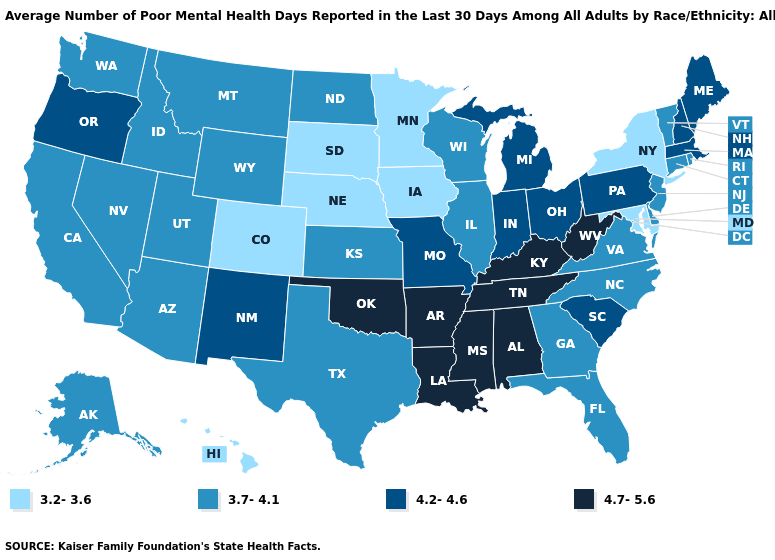Does North Carolina have the same value as South Carolina?
Give a very brief answer. No. What is the value of Florida?
Be succinct. 3.7-4.1. What is the value of Vermont?
Be succinct. 3.7-4.1. What is the value of Indiana?
Give a very brief answer. 4.2-4.6. Does Illinois have the highest value in the MidWest?
Be succinct. No. Does Utah have the same value as Delaware?
Keep it brief. Yes. Among the states that border Connecticut , which have the lowest value?
Keep it brief. New York. Does North Carolina have a higher value than Oklahoma?
Answer briefly. No. Among the states that border Maryland , which have the lowest value?
Quick response, please. Delaware, Virginia. Name the states that have a value in the range 3.7-4.1?
Keep it brief. Alaska, Arizona, California, Connecticut, Delaware, Florida, Georgia, Idaho, Illinois, Kansas, Montana, Nevada, New Jersey, North Carolina, North Dakota, Rhode Island, Texas, Utah, Vermont, Virginia, Washington, Wisconsin, Wyoming. What is the lowest value in states that border Utah?
Write a very short answer. 3.2-3.6. Name the states that have a value in the range 4.7-5.6?
Short answer required. Alabama, Arkansas, Kentucky, Louisiana, Mississippi, Oklahoma, Tennessee, West Virginia. How many symbols are there in the legend?
Write a very short answer. 4. Does New York have the lowest value in the Northeast?
Concise answer only. Yes. Which states have the highest value in the USA?
Keep it brief. Alabama, Arkansas, Kentucky, Louisiana, Mississippi, Oklahoma, Tennessee, West Virginia. 